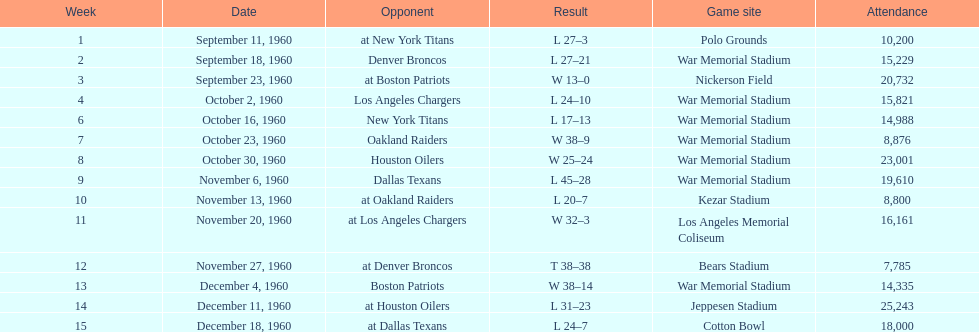What was the highest disparity in points during a single game? 29. 